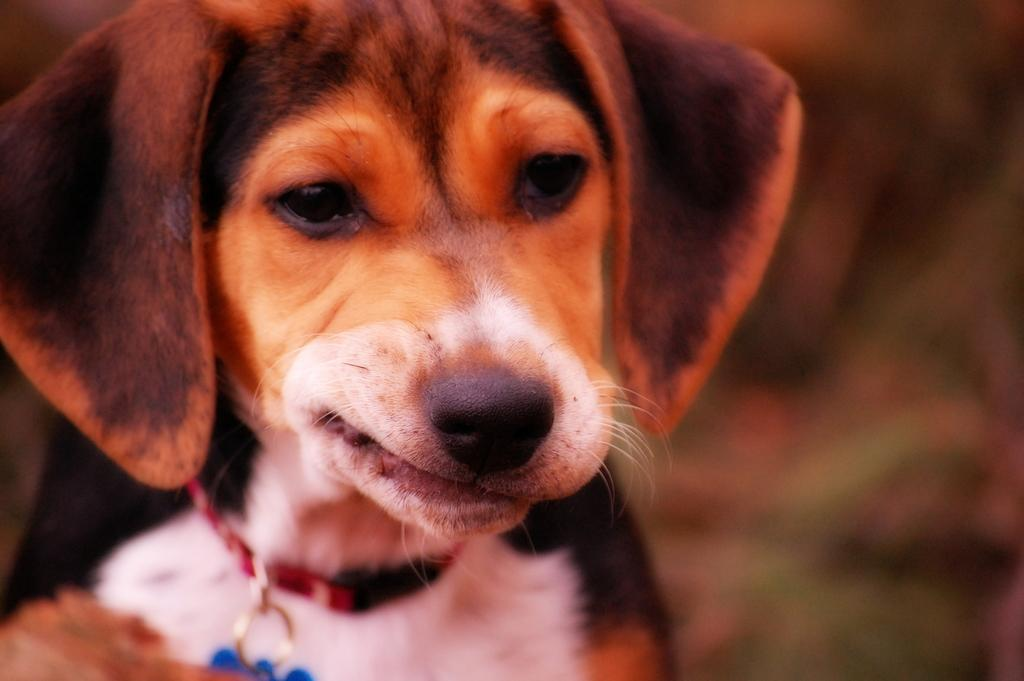What type of animal is in the image? There is a dog in the image. What is the dog wearing? The dog is wearing a belt. What color is the locket on the belt? The belt has a blue locket. How would you describe the background of the image? The background of the image has a blurred view. What type of spring is visible in the image? There is no spring present in the image. What magical powers does the dog possess in the image? The image does not depict any magical powers or abilities for the dog. 